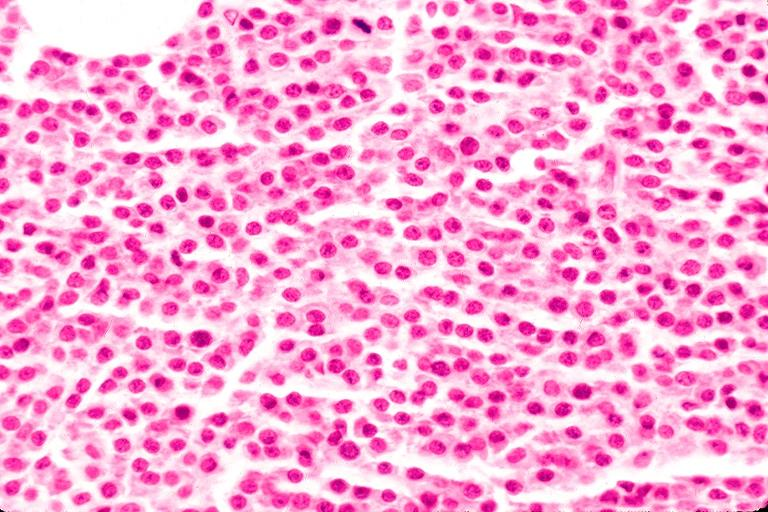what does this image show?
Answer the question using a single word or phrase. Multiple myeloma 